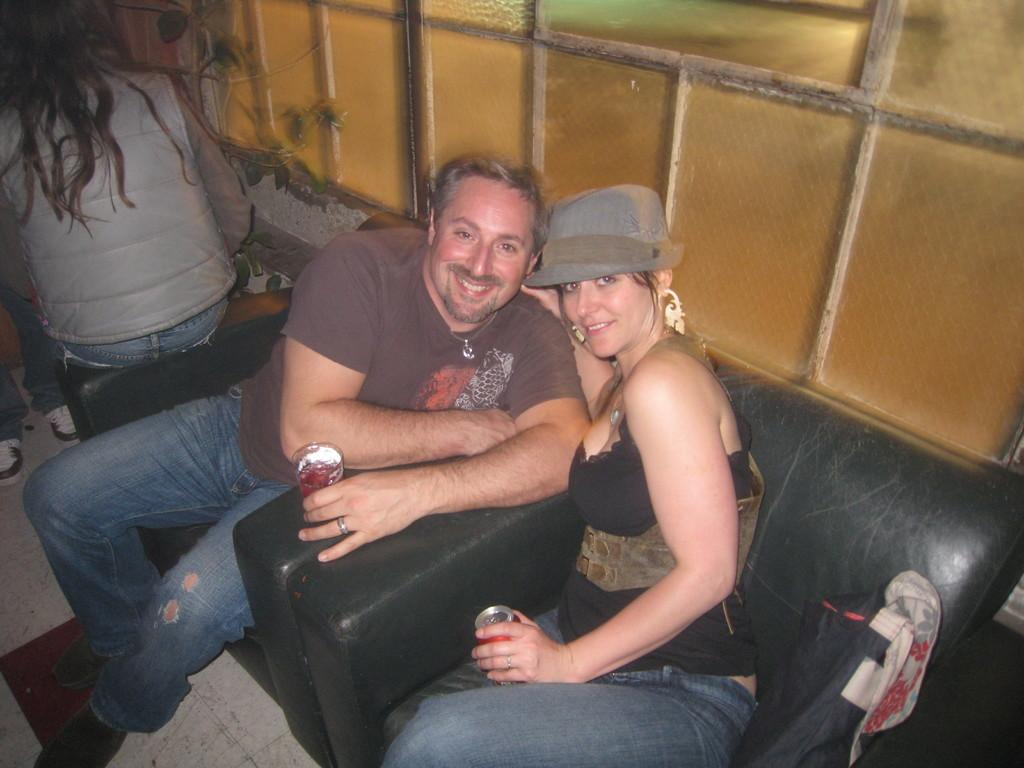How many people are in the image? There are people in the image. What are two of the people doing in the image? Two people are holding objects in the image. What type of surface can be seen under the people's feet? There is ground visible in the image. What type of furniture is present in the image? There is a sofa in the image. What type of architectural feature is present in the image? There is a glass wall in the image. What type of living organism is present in the image? There is a plant in the image. How does the baby contribute to the growth of the plant in the image? There is no baby present in the image, so it cannot contribute to the growth of the plant. 